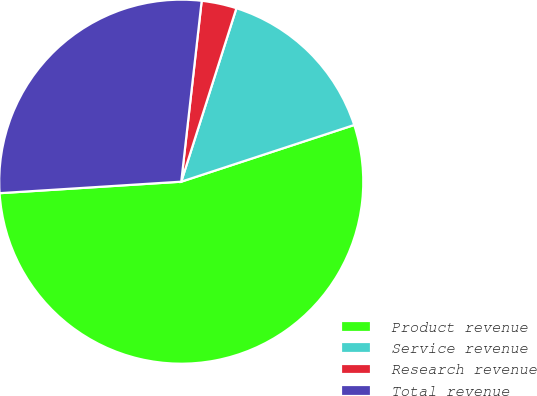Convert chart to OTSL. <chart><loc_0><loc_0><loc_500><loc_500><pie_chart><fcel>Product revenue<fcel>Service revenue<fcel>Research revenue<fcel>Total revenue<nl><fcel>54.04%<fcel>15.06%<fcel>3.11%<fcel>27.8%<nl></chart> 